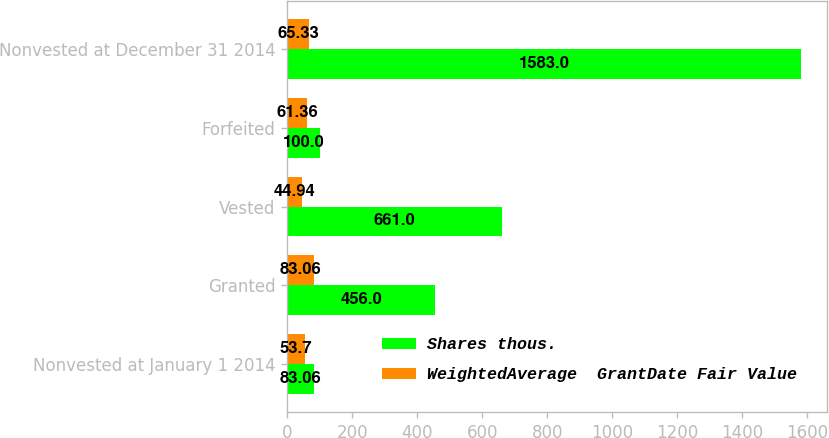<chart> <loc_0><loc_0><loc_500><loc_500><stacked_bar_chart><ecel><fcel>Nonvested at January 1 2014<fcel>Granted<fcel>Vested<fcel>Forfeited<fcel>Nonvested at December 31 2014<nl><fcel>Shares thous.<fcel>83.06<fcel>456<fcel>661<fcel>100<fcel>1583<nl><fcel>WeightedAverage  GrantDate Fair Value<fcel>53.7<fcel>83.06<fcel>44.94<fcel>61.36<fcel>65.33<nl></chart> 